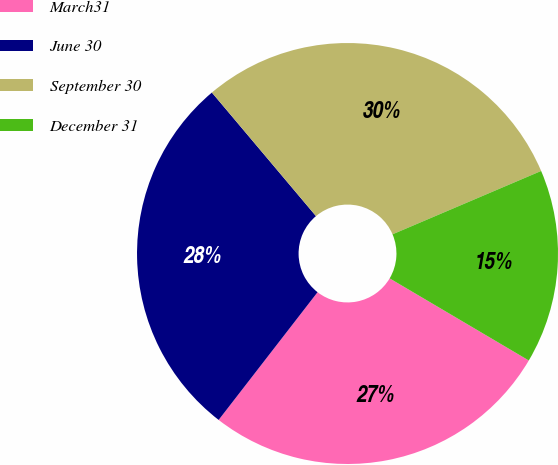Convert chart to OTSL. <chart><loc_0><loc_0><loc_500><loc_500><pie_chart><fcel>March31<fcel>June 30<fcel>September 30<fcel>December 31<nl><fcel>27.0%<fcel>28.37%<fcel>29.73%<fcel>14.9%<nl></chart> 